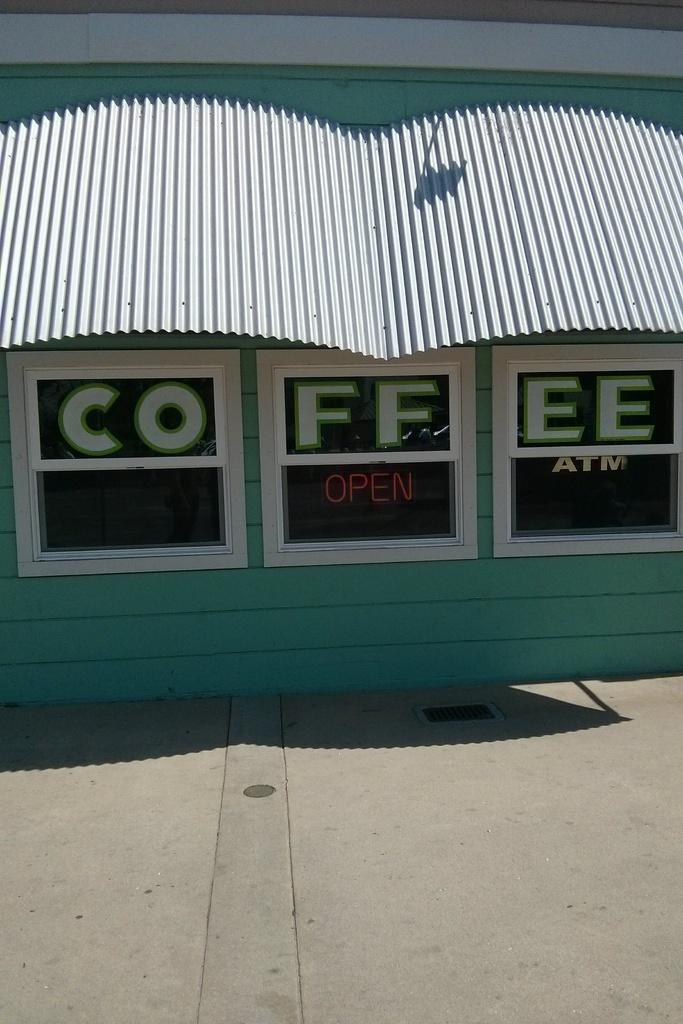What is the main structure in the center of the image? There is a building in the center of the image. What are some features of the building? The building has a wall and a roof sheet. Is there any text visible on the building? Yes, there is text visible on the building. What is located in front of the building? There is a platform in front of the building. What type of wilderness can be seen surrounding the building in the image? There is no wilderness visible in the image; it features a building with a wall, roof sheet, text, and a platform in front of it. 